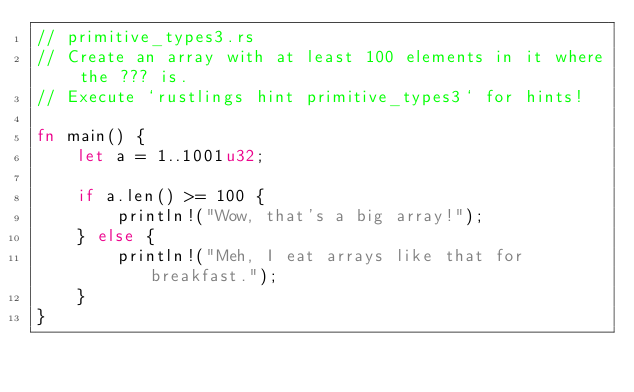<code> <loc_0><loc_0><loc_500><loc_500><_Rust_>// primitive_types3.rs
// Create an array with at least 100 elements in it where the ??? is.
// Execute `rustlings hint primitive_types3` for hints!

fn main() {
    let a = 1..1001u32;

    if a.len() >= 100 {
        println!("Wow, that's a big array!");
    } else {
        println!("Meh, I eat arrays like that for breakfast.");
    }
}
</code> 